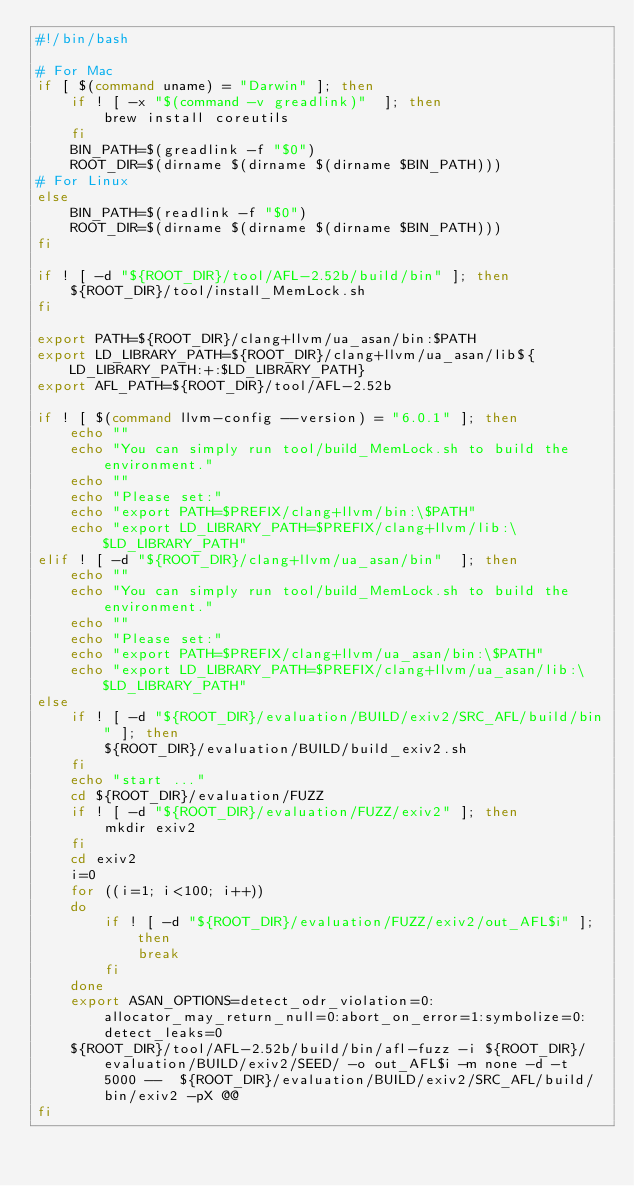Convert code to text. <code><loc_0><loc_0><loc_500><loc_500><_Bash_>#!/bin/bash

# For Mac
if [ $(command uname) = "Darwin" ]; then
    if ! [ -x "$(command -v greadlink)"  ]; then
        brew install coreutils
    fi
    BIN_PATH=$(greadlink -f "$0")
    ROOT_DIR=$(dirname $(dirname $(dirname $BIN_PATH)))
# For Linux
else
    BIN_PATH=$(readlink -f "$0")
    ROOT_DIR=$(dirname $(dirname $(dirname $BIN_PATH)))
fi

if ! [ -d "${ROOT_DIR}/tool/AFL-2.52b/build/bin" ]; then
	${ROOT_DIR}/tool/install_MemLock.sh
fi

export PATH=${ROOT_DIR}/clang+llvm/ua_asan/bin:$PATH
export LD_LIBRARY_PATH=${ROOT_DIR}/clang+llvm/ua_asan/lib${LD_LIBRARY_PATH:+:$LD_LIBRARY_PATH}
export AFL_PATH=${ROOT_DIR}/tool/AFL-2.52b

if ! [ $(command llvm-config --version) = "6.0.1" ]; then
	echo ""
	echo "You can simply run tool/build_MemLock.sh to build the environment."
	echo ""
	echo "Please set:"
	echo "export PATH=$PREFIX/clang+llvm/bin:\$PATH"
	echo "export LD_LIBRARY_PATH=$PREFIX/clang+llvm/lib:\$LD_LIBRARY_PATH"
elif ! [ -d "${ROOT_DIR}/clang+llvm/ua_asan/bin"  ]; then
	echo ""
	echo "You can simply run tool/build_MemLock.sh to build the environment."
	echo ""
	echo "Please set:"
	echo "export PATH=$PREFIX/clang+llvm/ua_asan/bin:\$PATH"
	echo "export LD_LIBRARY_PATH=$PREFIX/clang+llvm/ua_asan/lib:\$LD_LIBRARY_PATH"
else
	if ! [ -d "${ROOT_DIR}/evaluation/BUILD/exiv2/SRC_AFL/build/bin" ]; then
		${ROOT_DIR}/evaluation/BUILD/build_exiv2.sh
	fi
	echo "start ..."
	cd ${ROOT_DIR}/evaluation/FUZZ
	if ! [ -d "${ROOT_DIR}/evaluation/FUZZ/exiv2" ]; then
		mkdir exiv2
	fi
	cd exiv2
	i=0
	for ((i=1; i<100; i++))
	do
		if ! [ -d "${ROOT_DIR}/evaluation/FUZZ/exiv2/out_AFL$i" ]; then
			break
		fi
	done
	export ASAN_OPTIONS=detect_odr_violation=0:allocator_may_return_null=0:abort_on_error=1:symbolize=0:detect_leaks=0
	${ROOT_DIR}/tool/AFL-2.52b/build/bin/afl-fuzz -i ${ROOT_DIR}/evaluation/BUILD/exiv2/SEED/ -o out_AFL$i -m none -d -t 5000 --  ${ROOT_DIR}/evaluation/BUILD/exiv2/SRC_AFL/build/bin/exiv2 -pX @@
fi
</code> 